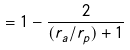<formula> <loc_0><loc_0><loc_500><loc_500>= 1 - \frac { 2 } { ( r _ { a } / r _ { p } ) + 1 }</formula> 